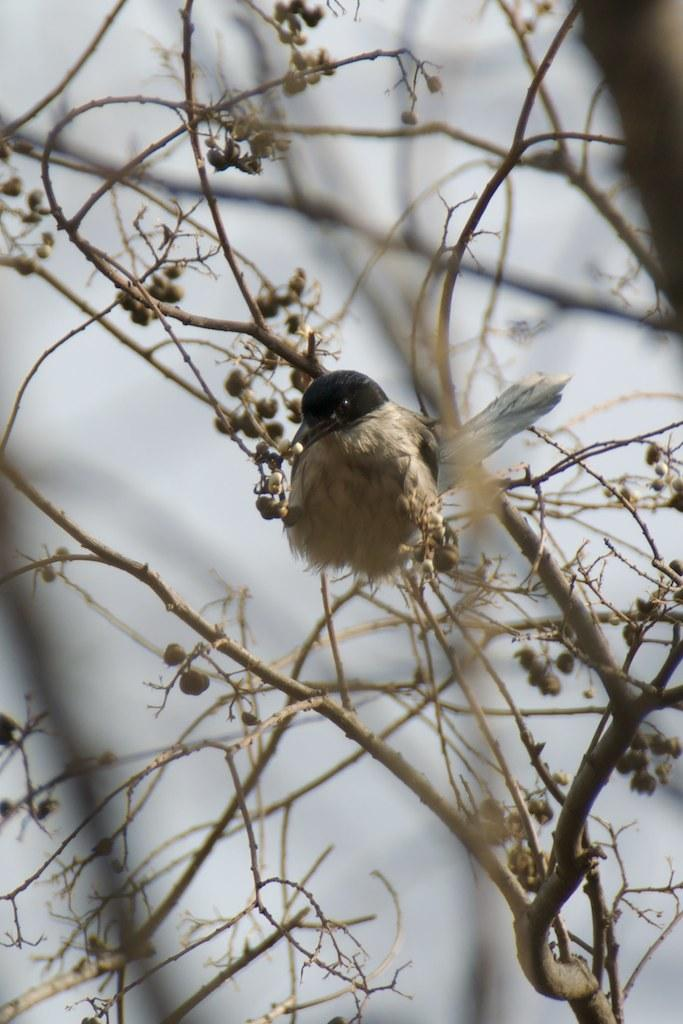What type of animal can be seen in the image? There is a bird in the image. Where is the bird located? The bird is on a tree. Can you describe any other objects on the tree? There might be fruits on the tree. How would you describe the background of the image? The background of the image is blurry. What color is the thread used to tie the sail in the image? There is no thread or sail present in the image; it features a bird on a tree with possibly some fruits. 